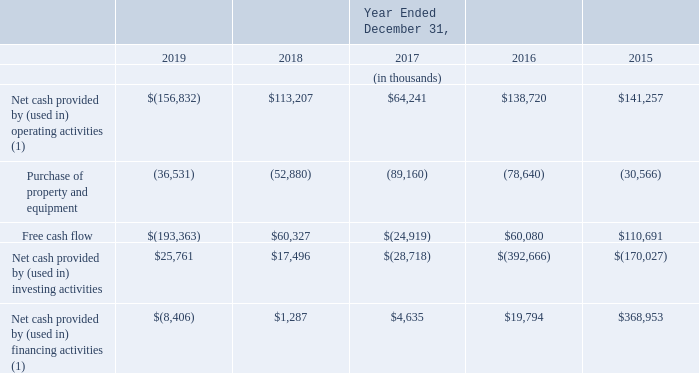Free cash flow
We define free cash flow as net cash provided by (used in) operating activities less purchase of property and equipment. We consider free cash flow to be a liquidity measure that provides useful information to management and investors about the amount of cash generated by the business that can possibly be used for investing in our business and strengthening the balance sheet, but it is not intended to represent the residual cash flow available for discretionary expenditures. Free cash flow is not prepared in accordance with U.S. GAAP, and should not be considered in isolation of, or as an alternative to, measures prepared in accordance with U.S. GAAP.
The following table presents a reconciliation of net cash provided by (used in) operating activities to free cash flow:
(1) Our adoption of ASU 2016-09 on January 1, 2017 resulted in excess tax benefits for share-based payments recorded as a reduction of income tax expense and reflected within operating cash flows, rather than recorded within equity and reflected within financing cash flows. We elected to adopt this new standard retrospectively, which impacted the presentation for all periods prior to the adoption date.
How does the company define free cash flows? Net cash provided by (used in) operating activities less purchase of property and equipment. When did the company adopt ASU 2016-09? January 1, 2017. What is the net cash provided by operating activities in 2015?
Answer scale should be: thousand. $141,257. What is the difference in the net cash provided by investing activities between 2018 and 2019?
Answer scale should be: thousand. 25,761-17,496
Answer: 8265. What is the average net cash provided by operating activities for 2016 and 2017?
Answer scale should be: thousand. (64,241+138,720)/2
Answer: 101480.5. What is the percentage change for net cash provided by financing activities from 2017 to 2018?
Answer scale should be: percent. (4,635-1,287)/4,635
Answer: 72.23. 